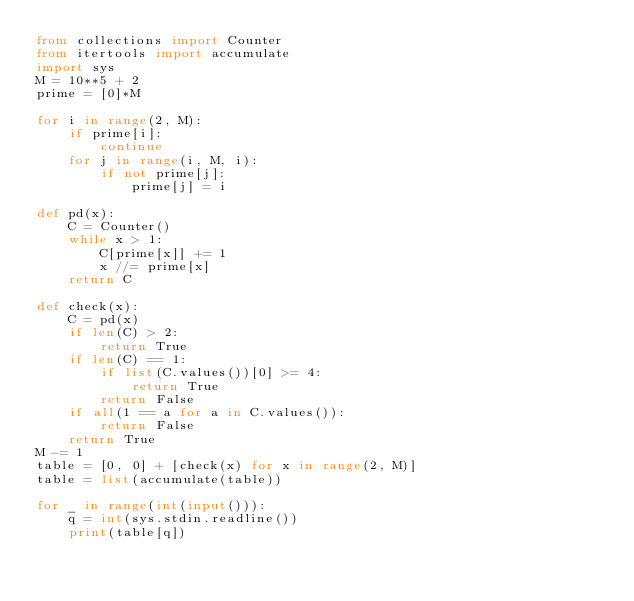<code> <loc_0><loc_0><loc_500><loc_500><_Python_>from collections import Counter
from itertools import accumulate
import sys
M = 10**5 + 2
prime = [0]*M

for i in range(2, M):
    if prime[i]:
        continue
    for j in range(i, M, i):
        if not prime[j]:
            prime[j] = i

def pd(x):
    C = Counter()
    while x > 1:
        C[prime[x]] += 1
        x //= prime[x]
    return C

def check(x):
    C = pd(x)
    if len(C) > 2:
        return True
    if len(C) == 1:
        if list(C.values())[0] >= 4:
            return True
        return False
    if all(1 == a for a in C.values()):
        return False
    return True
M -= 1
table = [0, 0] + [check(x) for x in range(2, M)] 
table = list(accumulate(table))

for _ in range(int(input())):
    q = int(sys.stdin.readline())
    print(table[q])

</code> 